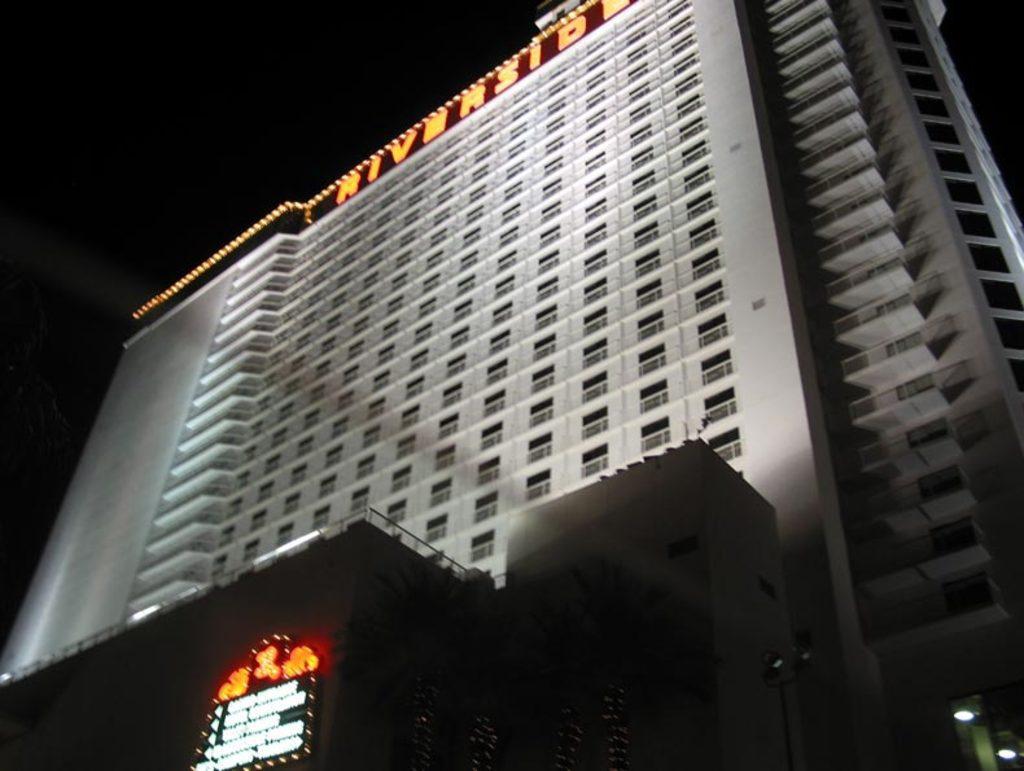Can you describe this image briefly? In this image we can see a building, lights, name board, glass windows and other objects. The background of the image is dark. 